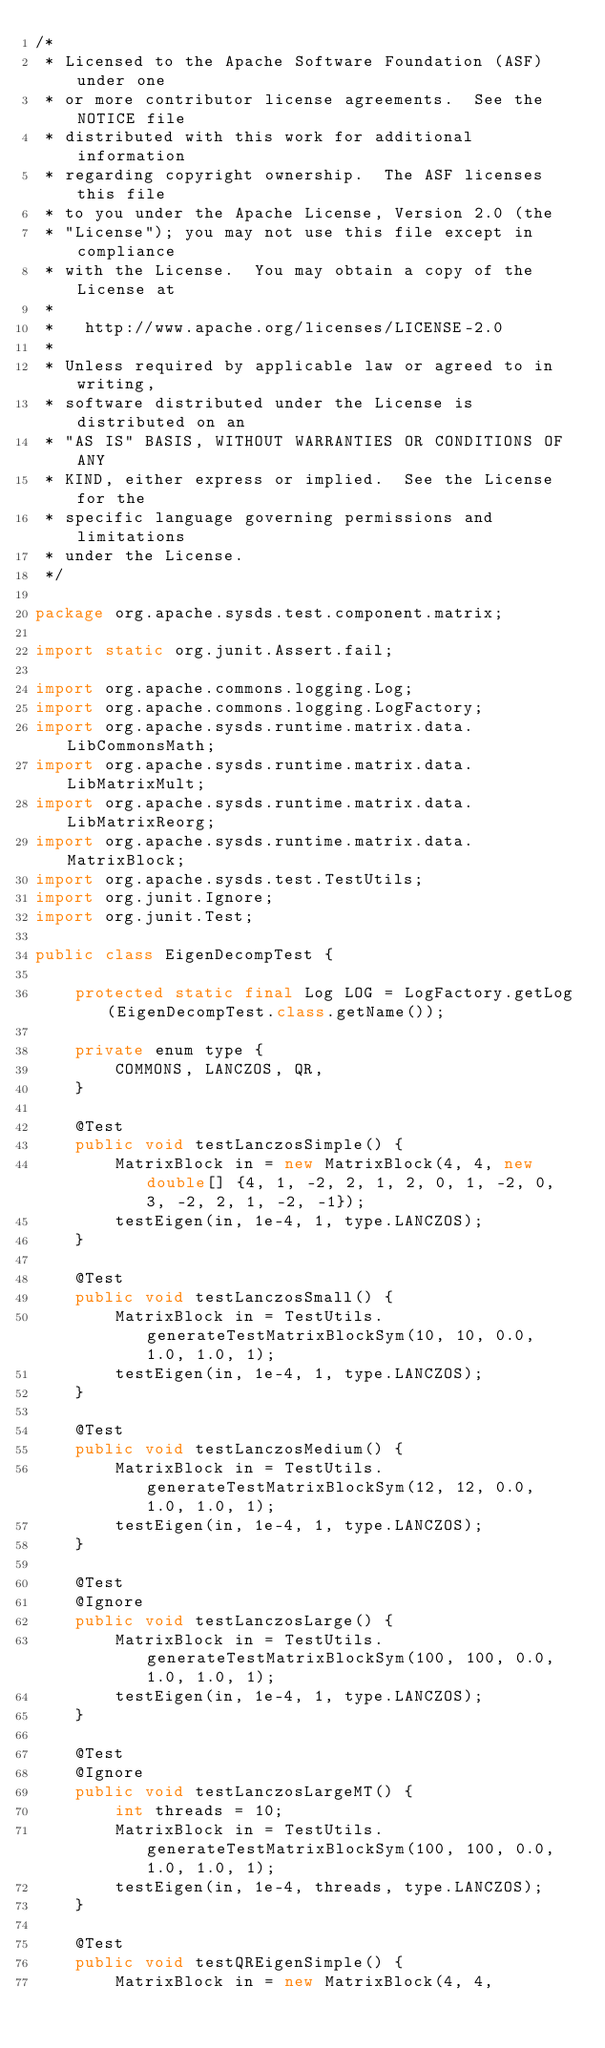Convert code to text. <code><loc_0><loc_0><loc_500><loc_500><_Java_>/*
 * Licensed to the Apache Software Foundation (ASF) under one
 * or more contributor license agreements.  See the NOTICE file
 * distributed with this work for additional information
 * regarding copyright ownership.  The ASF licenses this file
 * to you under the Apache License, Version 2.0 (the
 * "License"); you may not use this file except in compliance
 * with the License.  You may obtain a copy of the License at
 *
 *   http://www.apache.org/licenses/LICENSE-2.0
 *
 * Unless required by applicable law or agreed to in writing,
 * software distributed under the License is distributed on an
 * "AS IS" BASIS, WITHOUT WARRANTIES OR CONDITIONS OF ANY
 * KIND, either express or implied.  See the License for the
 * specific language governing permissions and limitations
 * under the License.
 */

package org.apache.sysds.test.component.matrix;

import static org.junit.Assert.fail;

import org.apache.commons.logging.Log;
import org.apache.commons.logging.LogFactory;
import org.apache.sysds.runtime.matrix.data.LibCommonsMath;
import org.apache.sysds.runtime.matrix.data.LibMatrixMult;
import org.apache.sysds.runtime.matrix.data.LibMatrixReorg;
import org.apache.sysds.runtime.matrix.data.MatrixBlock;
import org.apache.sysds.test.TestUtils;
import org.junit.Ignore;
import org.junit.Test;

public class EigenDecompTest {

	protected static final Log LOG = LogFactory.getLog(EigenDecompTest.class.getName());

	private enum type {
		COMMONS, LANCZOS, QR,
	}

	@Test
	public void testLanczosSimple() {
		MatrixBlock in = new MatrixBlock(4, 4, new double[] {4, 1, -2, 2, 1, 2, 0, 1, -2, 0, 3, -2, 2, 1, -2, -1});
		testEigen(in, 1e-4, 1, type.LANCZOS);
	}

	@Test
	public void testLanczosSmall() {
		MatrixBlock in = TestUtils.generateTestMatrixBlockSym(10, 10, 0.0, 1.0, 1.0, 1);
		testEigen(in, 1e-4, 1, type.LANCZOS);
	}

	@Test
	public void testLanczosMedium() {
		MatrixBlock in = TestUtils.generateTestMatrixBlockSym(12, 12, 0.0, 1.0, 1.0, 1);
		testEigen(in, 1e-4, 1, type.LANCZOS);
	}

	@Test
	@Ignore
	public void testLanczosLarge() {
		MatrixBlock in = TestUtils.generateTestMatrixBlockSym(100, 100, 0.0, 1.0, 1.0, 1);
		testEigen(in, 1e-4, 1, type.LANCZOS);
	}

	@Test
	@Ignore
	public void testLanczosLargeMT() {
		int threads = 10;
		MatrixBlock in = TestUtils.generateTestMatrixBlockSym(100, 100, 0.0, 1.0, 1.0, 1);
		testEigen(in, 1e-4, threads, type.LANCZOS);
	}

	@Test
	public void testQREigenSimple() {
		MatrixBlock in = new MatrixBlock(4, 4,</code> 